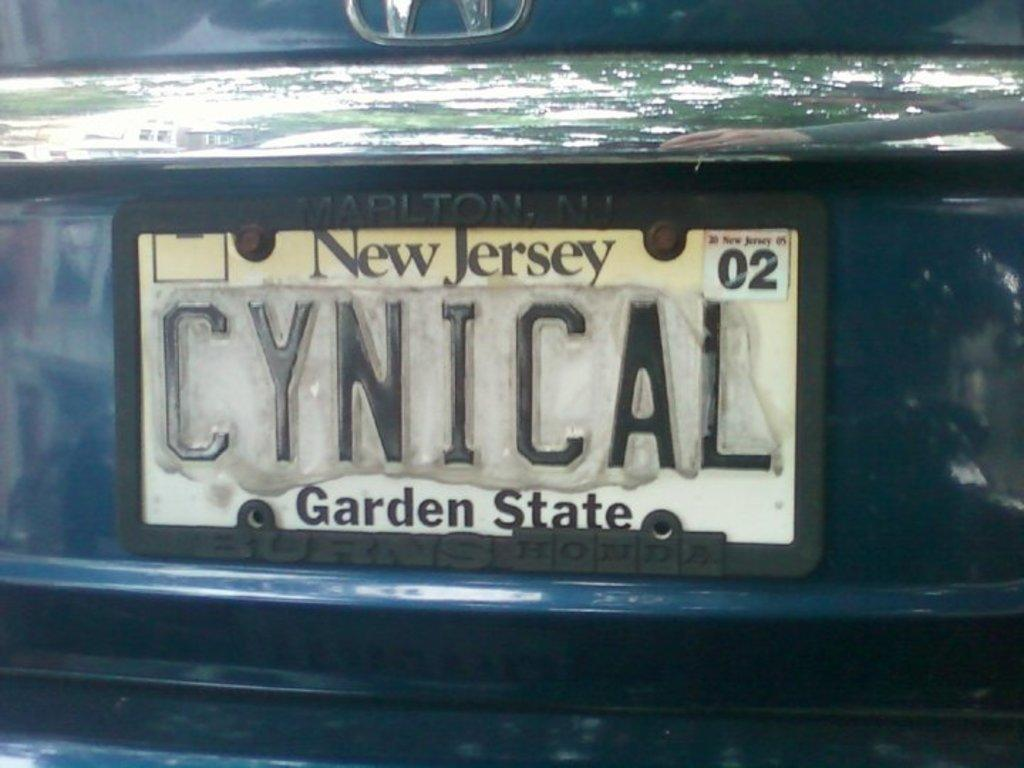<image>
Write a terse but informative summary of the picture. a New jersey license plate that is on a car 